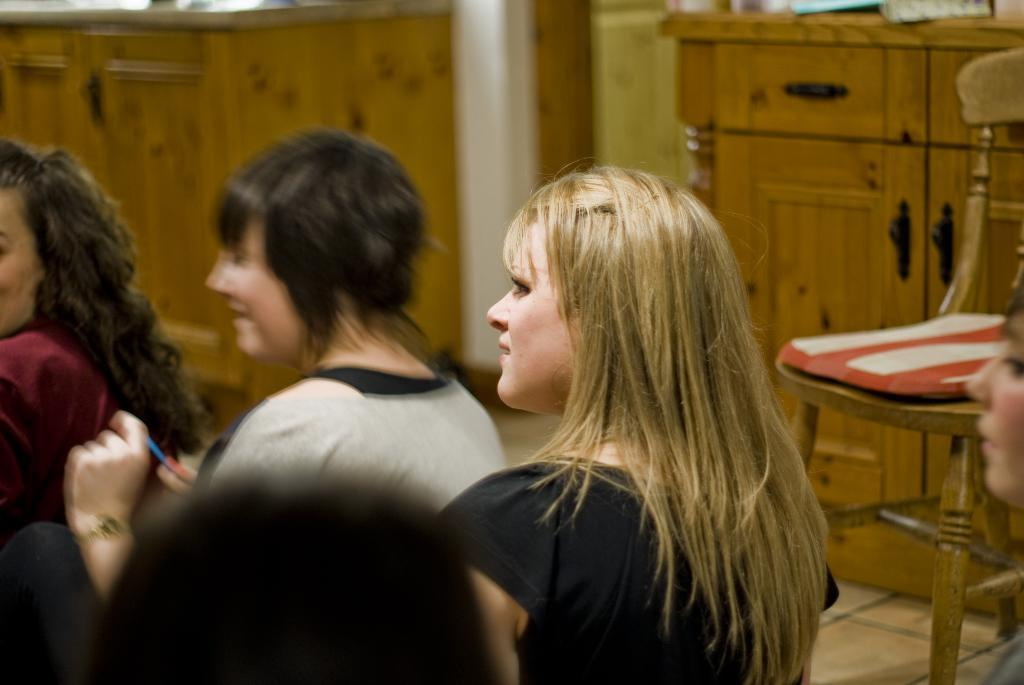Who is present in the image? There are women in the image. What piece of furniture can be seen in the image? There is a chair in the image. Is there any storage furniture in the image? Yes, there is a cupboard in the image. What crime is being committed in the image? There is no crime being committed in the image; it only shows women, a chair, and a cupboard. 